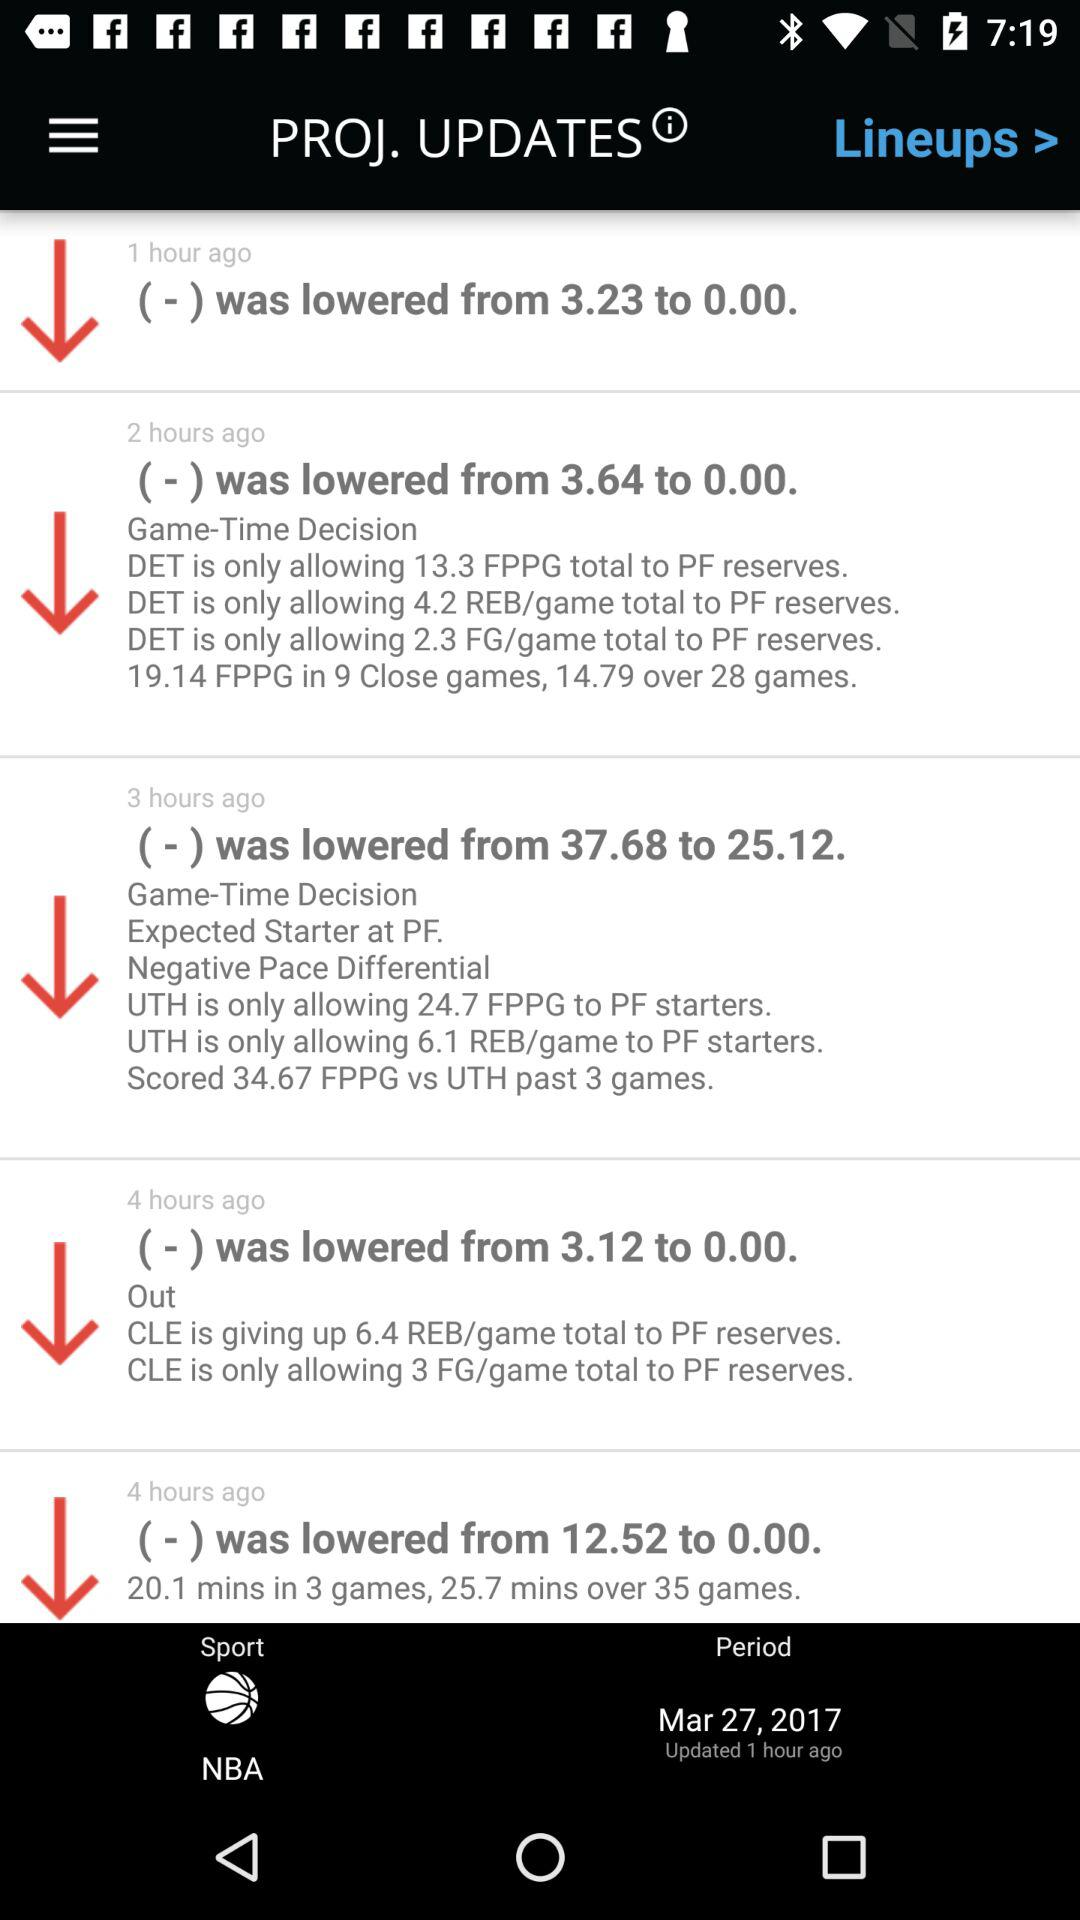How many hours ago was the last update?
Answer the question using a single word or phrase. 1 hour ago 